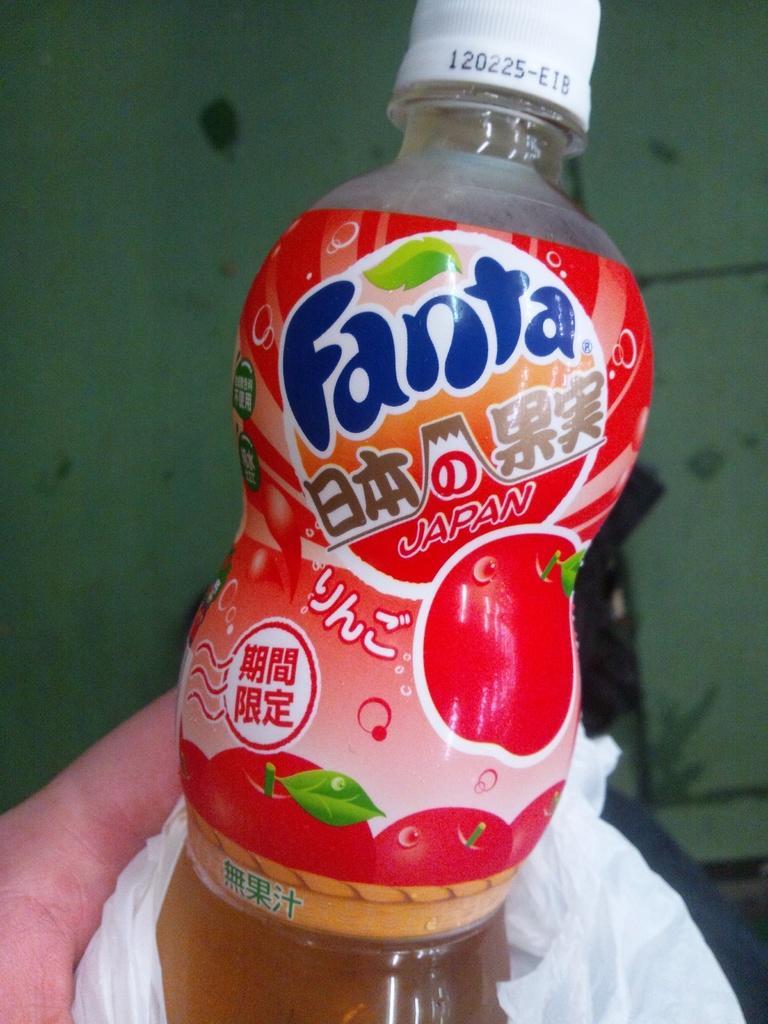Could you give a brief overview of what you see in this image? In the picture a hand is holding a juice bottle. There is label on it and on the label there is text Fanta, apples, leaves and text in Japanese language. On the cap of the bottle there are some numbers. The bottle is wrapped in a plastic cover. In the background there is a wall. 